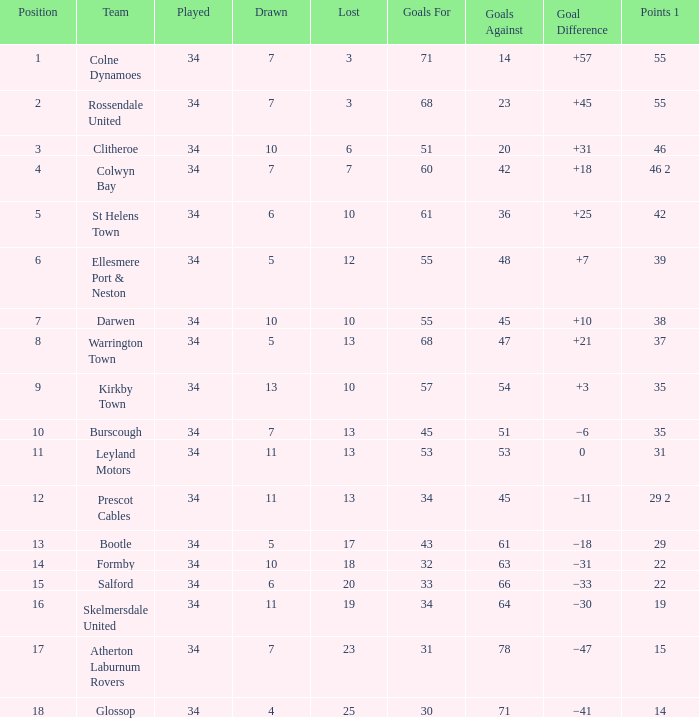Which Position has 47 Goals Against, and a Played larger than 34? None. Parse the table in full. {'header': ['Position', 'Team', 'Played', 'Drawn', 'Lost', 'Goals For', 'Goals Against', 'Goal Difference', 'Points 1'], 'rows': [['1', 'Colne Dynamoes', '34', '7', '3', '71', '14', '+57', '55'], ['2', 'Rossendale United', '34', '7', '3', '68', '23', '+45', '55'], ['3', 'Clitheroe', '34', '10', '6', '51', '20', '+31', '46'], ['4', 'Colwyn Bay', '34', '7', '7', '60', '42', '+18', '46 2'], ['5', 'St Helens Town', '34', '6', '10', '61', '36', '+25', '42'], ['6', 'Ellesmere Port & Neston', '34', '5', '12', '55', '48', '+7', '39'], ['7', 'Darwen', '34', '10', '10', '55', '45', '+10', '38'], ['8', 'Warrington Town', '34', '5', '13', '68', '47', '+21', '37'], ['9', 'Kirkby Town', '34', '13', '10', '57', '54', '+3', '35'], ['10', 'Burscough', '34', '7', '13', '45', '51', '−6', '35'], ['11', 'Leyland Motors', '34', '11', '13', '53', '53', '0', '31'], ['12', 'Prescot Cables', '34', '11', '13', '34', '45', '−11', '29 2'], ['13', 'Bootle', '34', '5', '17', '43', '61', '−18', '29'], ['14', 'Formby', '34', '10', '18', '32', '63', '−31', '22'], ['15', 'Salford', '34', '6', '20', '33', '66', '−33', '22'], ['16', 'Skelmersdale United', '34', '11', '19', '34', '64', '−30', '19'], ['17', 'Atherton Laburnum Rovers', '34', '7', '23', '31', '78', '−47', '15'], ['18', 'Glossop', '34', '4', '25', '30', '71', '−41', '14']]} 